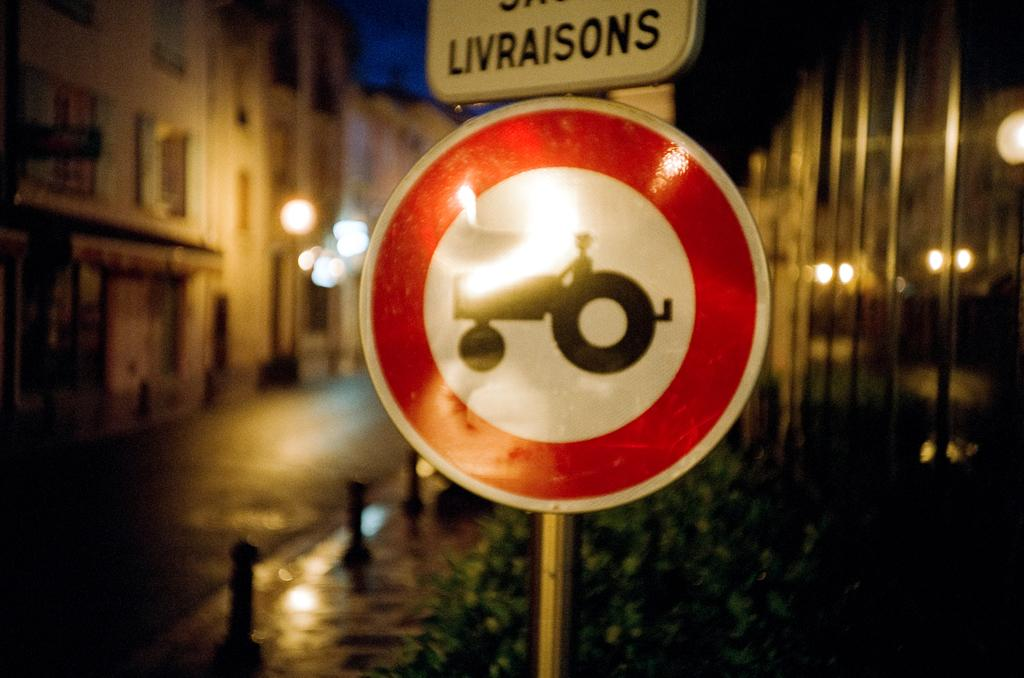Provide a one-sentence caption for the provided image. A round red and white sign has a tractor on it and a sign above it that says Livraisons. 